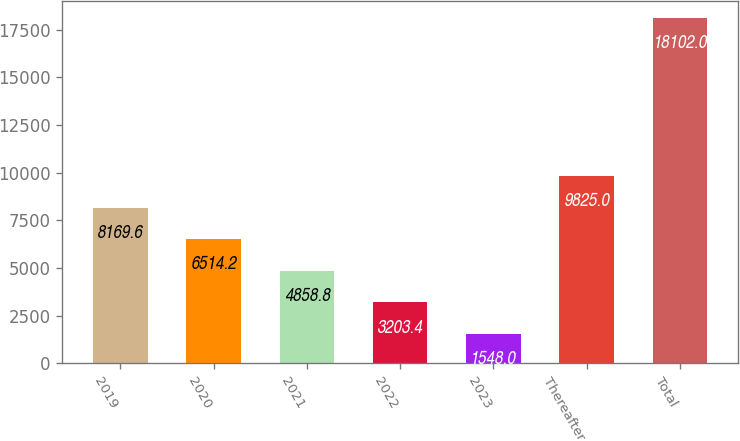Convert chart to OTSL. <chart><loc_0><loc_0><loc_500><loc_500><bar_chart><fcel>2019<fcel>2020<fcel>2021<fcel>2022<fcel>2023<fcel>Thereafter<fcel>Total<nl><fcel>8169.6<fcel>6514.2<fcel>4858.8<fcel>3203.4<fcel>1548<fcel>9825<fcel>18102<nl></chart> 